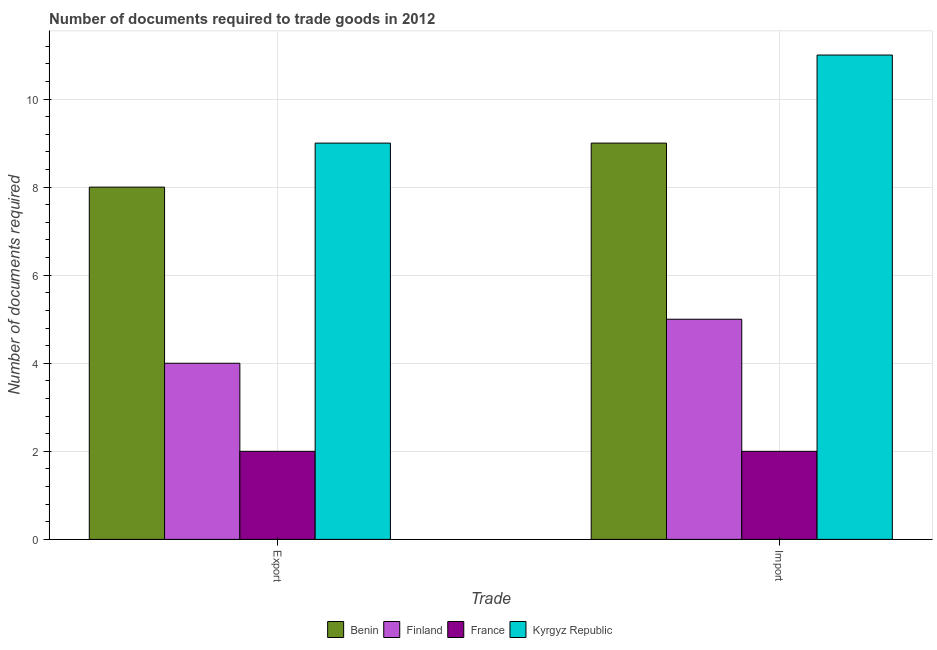How many groups of bars are there?
Offer a terse response. 2. How many bars are there on the 2nd tick from the left?
Your answer should be very brief. 4. What is the label of the 2nd group of bars from the left?
Give a very brief answer. Import. What is the number of documents required to import goods in Kyrgyz Republic?
Provide a short and direct response. 11. Across all countries, what is the maximum number of documents required to import goods?
Give a very brief answer. 11. Across all countries, what is the minimum number of documents required to import goods?
Offer a very short reply. 2. In which country was the number of documents required to import goods maximum?
Your answer should be compact. Kyrgyz Republic. In which country was the number of documents required to export goods minimum?
Provide a succinct answer. France. What is the total number of documents required to export goods in the graph?
Keep it short and to the point. 23. What is the difference between the number of documents required to import goods in Finland and that in Kyrgyz Republic?
Ensure brevity in your answer.  -6. What is the difference between the number of documents required to export goods in Finland and the number of documents required to import goods in Kyrgyz Republic?
Keep it short and to the point. -7. What is the average number of documents required to export goods per country?
Your answer should be compact. 5.75. What is the difference between the number of documents required to import goods and number of documents required to export goods in Finland?
Give a very brief answer. 1. In how many countries, is the number of documents required to import goods greater than 2 ?
Provide a succinct answer. 3. What is the ratio of the number of documents required to import goods in France to that in Benin?
Give a very brief answer. 0.22. Is the number of documents required to export goods in France less than that in Benin?
Provide a short and direct response. Yes. What does the 4th bar from the left in Import represents?
Offer a terse response. Kyrgyz Republic. What does the 2nd bar from the right in Export represents?
Your answer should be compact. France. How many bars are there?
Offer a terse response. 8. Are all the bars in the graph horizontal?
Your answer should be very brief. No. What is the difference between two consecutive major ticks on the Y-axis?
Provide a short and direct response. 2. Does the graph contain any zero values?
Keep it short and to the point. No. Does the graph contain grids?
Keep it short and to the point. Yes. How many legend labels are there?
Offer a terse response. 4. How are the legend labels stacked?
Offer a very short reply. Horizontal. What is the title of the graph?
Ensure brevity in your answer.  Number of documents required to trade goods in 2012. What is the label or title of the X-axis?
Keep it short and to the point. Trade. What is the label or title of the Y-axis?
Your response must be concise. Number of documents required. What is the Number of documents required of Benin in Export?
Offer a very short reply. 8. What is the Number of documents required of Finland in Export?
Ensure brevity in your answer.  4. What is the Number of documents required of Kyrgyz Republic in Export?
Offer a very short reply. 9. What is the Number of documents required of Benin in Import?
Your answer should be very brief. 9. Across all Trade, what is the maximum Number of documents required in Benin?
Keep it short and to the point. 9. Across all Trade, what is the maximum Number of documents required of France?
Offer a terse response. 2. Across all Trade, what is the minimum Number of documents required in Finland?
Provide a succinct answer. 4. What is the difference between the Number of documents required of Finland in Export and that in Import?
Provide a succinct answer. -1. What is the difference between the Number of documents required in Finland in Export and the Number of documents required in France in Import?
Offer a very short reply. 2. What is the difference between the Number of documents required in Finland in Export and the Number of documents required in Kyrgyz Republic in Import?
Give a very brief answer. -7. What is the average Number of documents required in Finland per Trade?
Give a very brief answer. 4.5. What is the average Number of documents required of France per Trade?
Offer a very short reply. 2. What is the difference between the Number of documents required in Benin and Number of documents required in Kyrgyz Republic in Export?
Your answer should be very brief. -1. What is the difference between the Number of documents required in Benin and Number of documents required in Finland in Import?
Provide a succinct answer. 4. What is the difference between the Number of documents required of Benin and Number of documents required of Kyrgyz Republic in Import?
Your answer should be compact. -2. What is the difference between the Number of documents required in France and Number of documents required in Kyrgyz Republic in Import?
Offer a very short reply. -9. What is the ratio of the Number of documents required of Benin in Export to that in Import?
Provide a succinct answer. 0.89. What is the ratio of the Number of documents required in Finland in Export to that in Import?
Keep it short and to the point. 0.8. What is the ratio of the Number of documents required of Kyrgyz Republic in Export to that in Import?
Offer a terse response. 0.82. What is the difference between the highest and the second highest Number of documents required in Benin?
Your answer should be compact. 1. What is the difference between the highest and the second highest Number of documents required in Finland?
Offer a terse response. 1. What is the difference between the highest and the second highest Number of documents required in France?
Ensure brevity in your answer.  0. What is the difference between the highest and the lowest Number of documents required in Benin?
Ensure brevity in your answer.  1. What is the difference between the highest and the lowest Number of documents required in France?
Make the answer very short. 0. 